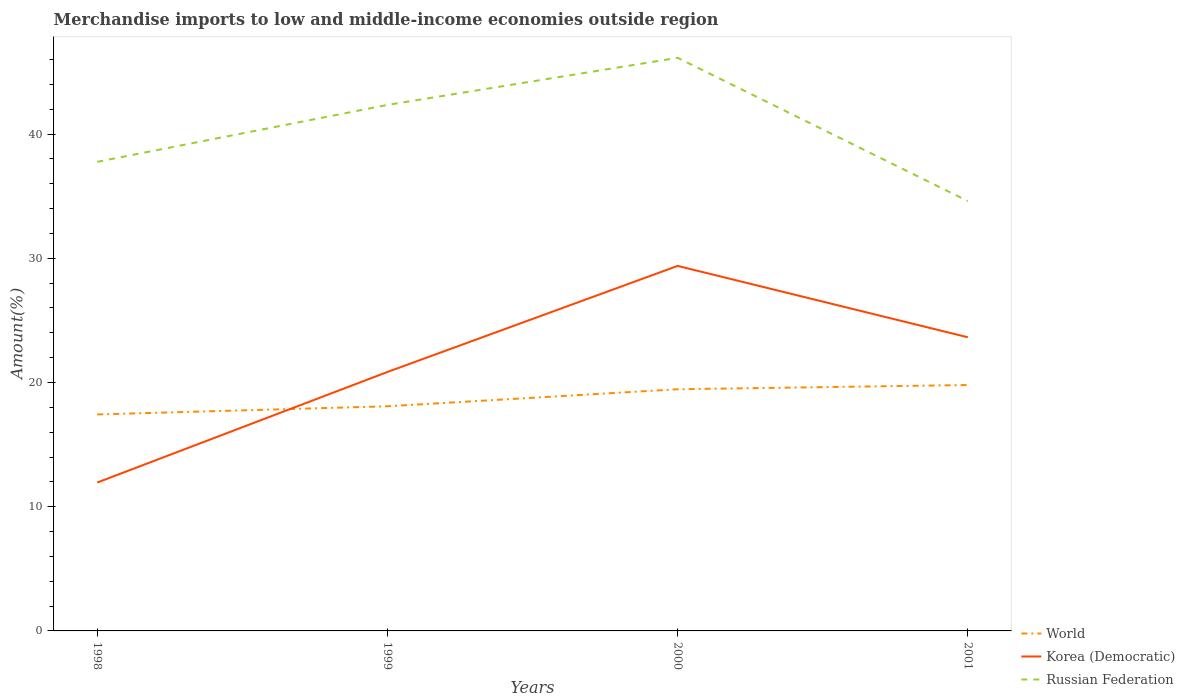Is the number of lines equal to the number of legend labels?
Give a very brief answer. Yes. Across all years, what is the maximum percentage of amount earned from merchandise imports in World?
Your response must be concise. 17.43. In which year was the percentage of amount earned from merchandise imports in World maximum?
Make the answer very short. 1998. What is the total percentage of amount earned from merchandise imports in World in the graph?
Provide a succinct answer. -2.37. What is the difference between the highest and the second highest percentage of amount earned from merchandise imports in Russian Federation?
Your answer should be very brief. 11.53. What is the difference between the highest and the lowest percentage of amount earned from merchandise imports in Russian Federation?
Keep it short and to the point. 2. Is the percentage of amount earned from merchandise imports in Korea (Democratic) strictly greater than the percentage of amount earned from merchandise imports in Russian Federation over the years?
Provide a succinct answer. Yes. How many lines are there?
Give a very brief answer. 3. How many years are there in the graph?
Your response must be concise. 4. Does the graph contain any zero values?
Offer a terse response. No. Does the graph contain grids?
Provide a short and direct response. No. What is the title of the graph?
Your answer should be compact. Merchandise imports to low and middle-income economies outside region. Does "Mauritania" appear as one of the legend labels in the graph?
Give a very brief answer. No. What is the label or title of the X-axis?
Provide a succinct answer. Years. What is the label or title of the Y-axis?
Provide a short and direct response. Amount(%). What is the Amount(%) in World in 1998?
Keep it short and to the point. 17.43. What is the Amount(%) of Korea (Democratic) in 1998?
Offer a very short reply. 11.95. What is the Amount(%) in Russian Federation in 1998?
Ensure brevity in your answer.  37.77. What is the Amount(%) in World in 1999?
Your answer should be very brief. 18.09. What is the Amount(%) in Korea (Democratic) in 1999?
Provide a succinct answer. 20.85. What is the Amount(%) of Russian Federation in 1999?
Offer a terse response. 42.35. What is the Amount(%) of World in 2000?
Provide a succinct answer. 19.46. What is the Amount(%) of Korea (Democratic) in 2000?
Make the answer very short. 29.39. What is the Amount(%) of Russian Federation in 2000?
Your answer should be very brief. 46.14. What is the Amount(%) in World in 2001?
Offer a terse response. 19.8. What is the Amount(%) of Korea (Democratic) in 2001?
Ensure brevity in your answer.  23.64. What is the Amount(%) of Russian Federation in 2001?
Keep it short and to the point. 34.61. Across all years, what is the maximum Amount(%) in World?
Ensure brevity in your answer.  19.8. Across all years, what is the maximum Amount(%) of Korea (Democratic)?
Keep it short and to the point. 29.39. Across all years, what is the maximum Amount(%) of Russian Federation?
Keep it short and to the point. 46.14. Across all years, what is the minimum Amount(%) of World?
Provide a short and direct response. 17.43. Across all years, what is the minimum Amount(%) of Korea (Democratic)?
Offer a very short reply. 11.95. Across all years, what is the minimum Amount(%) in Russian Federation?
Your response must be concise. 34.61. What is the total Amount(%) in World in the graph?
Your response must be concise. 74.77. What is the total Amount(%) of Korea (Democratic) in the graph?
Give a very brief answer. 85.82. What is the total Amount(%) of Russian Federation in the graph?
Keep it short and to the point. 160.86. What is the difference between the Amount(%) in World in 1998 and that in 1999?
Keep it short and to the point. -0.66. What is the difference between the Amount(%) in Korea (Democratic) in 1998 and that in 1999?
Provide a short and direct response. -8.9. What is the difference between the Amount(%) of Russian Federation in 1998 and that in 1999?
Give a very brief answer. -4.58. What is the difference between the Amount(%) in World in 1998 and that in 2000?
Keep it short and to the point. -2.03. What is the difference between the Amount(%) in Korea (Democratic) in 1998 and that in 2000?
Give a very brief answer. -17.44. What is the difference between the Amount(%) in Russian Federation in 1998 and that in 2000?
Make the answer very short. -8.37. What is the difference between the Amount(%) of World in 1998 and that in 2001?
Give a very brief answer. -2.37. What is the difference between the Amount(%) of Korea (Democratic) in 1998 and that in 2001?
Your answer should be compact. -11.7. What is the difference between the Amount(%) in Russian Federation in 1998 and that in 2001?
Make the answer very short. 3.16. What is the difference between the Amount(%) in World in 1999 and that in 2000?
Provide a short and direct response. -1.37. What is the difference between the Amount(%) of Korea (Democratic) in 1999 and that in 2000?
Make the answer very short. -8.54. What is the difference between the Amount(%) of Russian Federation in 1999 and that in 2000?
Make the answer very short. -3.79. What is the difference between the Amount(%) of World in 1999 and that in 2001?
Provide a succinct answer. -1.71. What is the difference between the Amount(%) in Korea (Democratic) in 1999 and that in 2001?
Your answer should be compact. -2.79. What is the difference between the Amount(%) in Russian Federation in 1999 and that in 2001?
Offer a very short reply. 7.74. What is the difference between the Amount(%) in World in 2000 and that in 2001?
Your response must be concise. -0.34. What is the difference between the Amount(%) of Korea (Democratic) in 2000 and that in 2001?
Give a very brief answer. 5.74. What is the difference between the Amount(%) of Russian Federation in 2000 and that in 2001?
Your answer should be very brief. 11.53. What is the difference between the Amount(%) in World in 1998 and the Amount(%) in Korea (Democratic) in 1999?
Provide a short and direct response. -3.42. What is the difference between the Amount(%) of World in 1998 and the Amount(%) of Russian Federation in 1999?
Provide a short and direct response. -24.92. What is the difference between the Amount(%) of Korea (Democratic) in 1998 and the Amount(%) of Russian Federation in 1999?
Give a very brief answer. -30.4. What is the difference between the Amount(%) in World in 1998 and the Amount(%) in Korea (Democratic) in 2000?
Your answer should be very brief. -11.96. What is the difference between the Amount(%) of World in 1998 and the Amount(%) of Russian Federation in 2000?
Offer a terse response. -28.71. What is the difference between the Amount(%) in Korea (Democratic) in 1998 and the Amount(%) in Russian Federation in 2000?
Give a very brief answer. -34.19. What is the difference between the Amount(%) in World in 1998 and the Amount(%) in Korea (Democratic) in 2001?
Your answer should be very brief. -6.21. What is the difference between the Amount(%) of World in 1998 and the Amount(%) of Russian Federation in 2001?
Your response must be concise. -17.18. What is the difference between the Amount(%) of Korea (Democratic) in 1998 and the Amount(%) of Russian Federation in 2001?
Your answer should be very brief. -22.66. What is the difference between the Amount(%) in World in 1999 and the Amount(%) in Korea (Democratic) in 2000?
Keep it short and to the point. -11.3. What is the difference between the Amount(%) in World in 1999 and the Amount(%) in Russian Federation in 2000?
Give a very brief answer. -28.05. What is the difference between the Amount(%) in Korea (Democratic) in 1999 and the Amount(%) in Russian Federation in 2000?
Your answer should be very brief. -25.29. What is the difference between the Amount(%) in World in 1999 and the Amount(%) in Korea (Democratic) in 2001?
Your response must be concise. -5.56. What is the difference between the Amount(%) in World in 1999 and the Amount(%) in Russian Federation in 2001?
Provide a short and direct response. -16.52. What is the difference between the Amount(%) of Korea (Democratic) in 1999 and the Amount(%) of Russian Federation in 2001?
Provide a short and direct response. -13.76. What is the difference between the Amount(%) in World in 2000 and the Amount(%) in Korea (Democratic) in 2001?
Offer a very short reply. -4.19. What is the difference between the Amount(%) of World in 2000 and the Amount(%) of Russian Federation in 2001?
Your answer should be very brief. -15.15. What is the difference between the Amount(%) of Korea (Democratic) in 2000 and the Amount(%) of Russian Federation in 2001?
Provide a short and direct response. -5.22. What is the average Amount(%) of World per year?
Your answer should be very brief. 18.69. What is the average Amount(%) of Korea (Democratic) per year?
Provide a succinct answer. 21.46. What is the average Amount(%) of Russian Federation per year?
Offer a terse response. 40.22. In the year 1998, what is the difference between the Amount(%) of World and Amount(%) of Korea (Democratic)?
Your answer should be very brief. 5.48. In the year 1998, what is the difference between the Amount(%) of World and Amount(%) of Russian Federation?
Your answer should be very brief. -20.34. In the year 1998, what is the difference between the Amount(%) of Korea (Democratic) and Amount(%) of Russian Federation?
Offer a terse response. -25.82. In the year 1999, what is the difference between the Amount(%) of World and Amount(%) of Korea (Democratic)?
Your response must be concise. -2.76. In the year 1999, what is the difference between the Amount(%) of World and Amount(%) of Russian Federation?
Your answer should be very brief. -24.26. In the year 1999, what is the difference between the Amount(%) in Korea (Democratic) and Amount(%) in Russian Federation?
Provide a succinct answer. -21.5. In the year 2000, what is the difference between the Amount(%) of World and Amount(%) of Korea (Democratic)?
Provide a succinct answer. -9.93. In the year 2000, what is the difference between the Amount(%) in World and Amount(%) in Russian Federation?
Provide a short and direct response. -26.68. In the year 2000, what is the difference between the Amount(%) of Korea (Democratic) and Amount(%) of Russian Federation?
Ensure brevity in your answer.  -16.75. In the year 2001, what is the difference between the Amount(%) of World and Amount(%) of Korea (Democratic)?
Offer a very short reply. -3.84. In the year 2001, what is the difference between the Amount(%) in World and Amount(%) in Russian Federation?
Offer a very short reply. -14.81. In the year 2001, what is the difference between the Amount(%) in Korea (Democratic) and Amount(%) in Russian Federation?
Your answer should be compact. -10.97. What is the ratio of the Amount(%) in World in 1998 to that in 1999?
Your response must be concise. 0.96. What is the ratio of the Amount(%) of Korea (Democratic) in 1998 to that in 1999?
Ensure brevity in your answer.  0.57. What is the ratio of the Amount(%) in Russian Federation in 1998 to that in 1999?
Your answer should be compact. 0.89. What is the ratio of the Amount(%) of World in 1998 to that in 2000?
Make the answer very short. 0.9. What is the ratio of the Amount(%) of Korea (Democratic) in 1998 to that in 2000?
Offer a very short reply. 0.41. What is the ratio of the Amount(%) of Russian Federation in 1998 to that in 2000?
Give a very brief answer. 0.82. What is the ratio of the Amount(%) in World in 1998 to that in 2001?
Give a very brief answer. 0.88. What is the ratio of the Amount(%) in Korea (Democratic) in 1998 to that in 2001?
Offer a very short reply. 0.51. What is the ratio of the Amount(%) of Russian Federation in 1998 to that in 2001?
Ensure brevity in your answer.  1.09. What is the ratio of the Amount(%) in World in 1999 to that in 2000?
Provide a short and direct response. 0.93. What is the ratio of the Amount(%) of Korea (Democratic) in 1999 to that in 2000?
Make the answer very short. 0.71. What is the ratio of the Amount(%) in Russian Federation in 1999 to that in 2000?
Make the answer very short. 0.92. What is the ratio of the Amount(%) in World in 1999 to that in 2001?
Provide a short and direct response. 0.91. What is the ratio of the Amount(%) of Korea (Democratic) in 1999 to that in 2001?
Your answer should be compact. 0.88. What is the ratio of the Amount(%) in Russian Federation in 1999 to that in 2001?
Make the answer very short. 1.22. What is the ratio of the Amount(%) in World in 2000 to that in 2001?
Make the answer very short. 0.98. What is the ratio of the Amount(%) in Korea (Democratic) in 2000 to that in 2001?
Offer a very short reply. 1.24. What is the ratio of the Amount(%) of Russian Federation in 2000 to that in 2001?
Offer a terse response. 1.33. What is the difference between the highest and the second highest Amount(%) of World?
Make the answer very short. 0.34. What is the difference between the highest and the second highest Amount(%) of Korea (Democratic)?
Your answer should be very brief. 5.74. What is the difference between the highest and the second highest Amount(%) of Russian Federation?
Your answer should be very brief. 3.79. What is the difference between the highest and the lowest Amount(%) in World?
Your answer should be compact. 2.37. What is the difference between the highest and the lowest Amount(%) of Korea (Democratic)?
Your response must be concise. 17.44. What is the difference between the highest and the lowest Amount(%) in Russian Federation?
Make the answer very short. 11.53. 